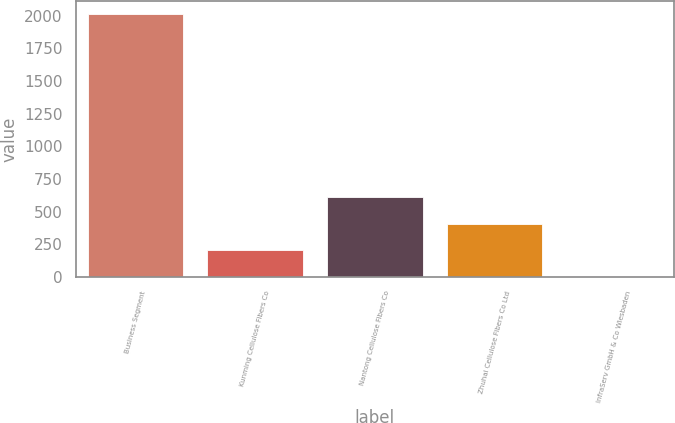<chart> <loc_0><loc_0><loc_500><loc_500><bar_chart><fcel>Business Segment<fcel>Kunming Cellulose Fibers Co<fcel>Nantong Cellulose Fibers Co<fcel>Zhuhai Cellulose Fibers Co Ltd<fcel>InfraServ GmbH & Co Wiesbaden<nl><fcel>2010<fcel>208.2<fcel>608.6<fcel>408.4<fcel>8<nl></chart> 